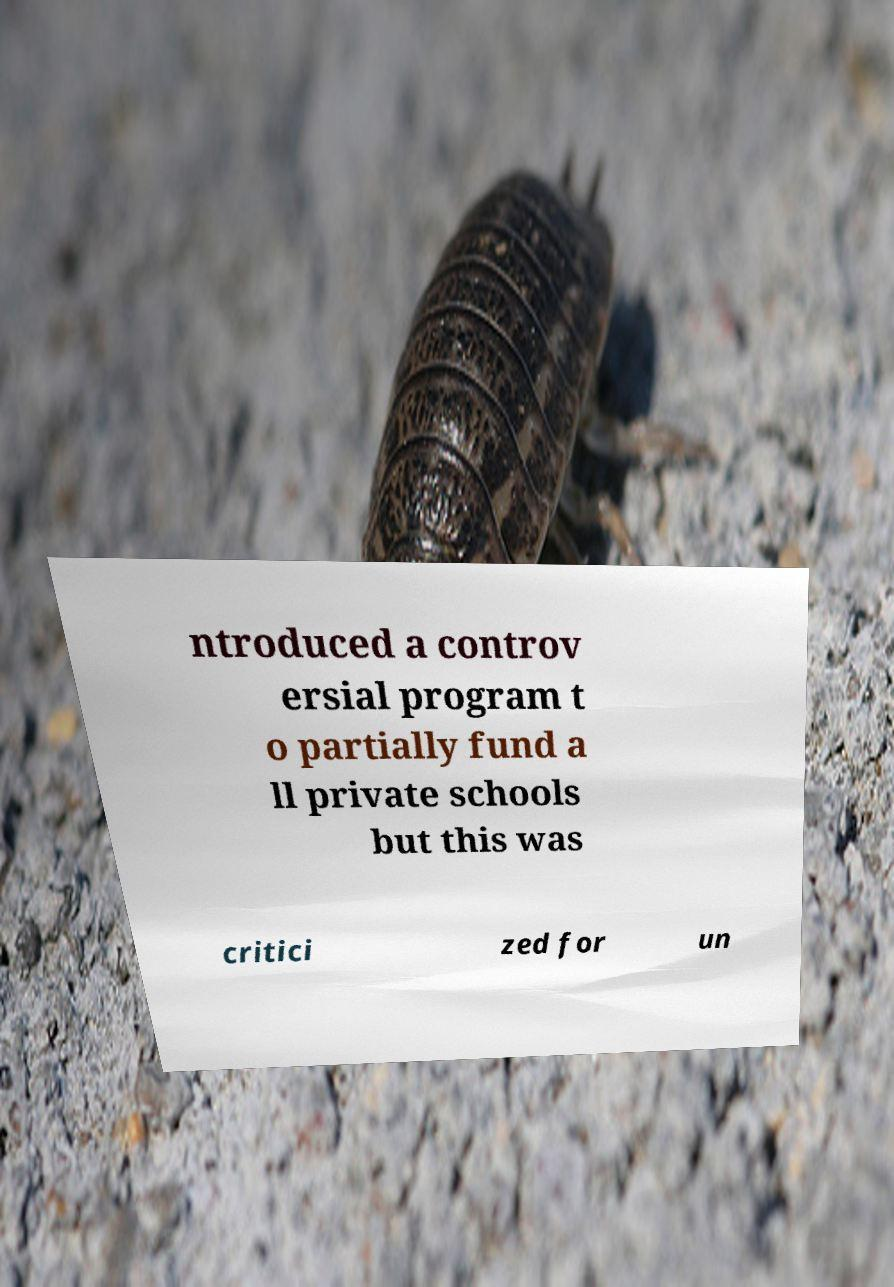What messages or text are displayed in this image? I need them in a readable, typed format. ntroduced a controv ersial program t o partially fund a ll private schools but this was critici zed for un 